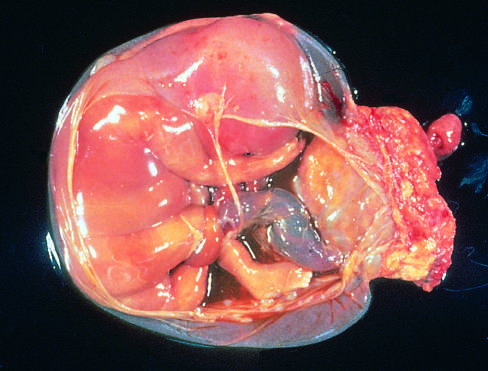what is at the right, in the specimen shown?
Answer the question using a single word or phrase. The placenta 